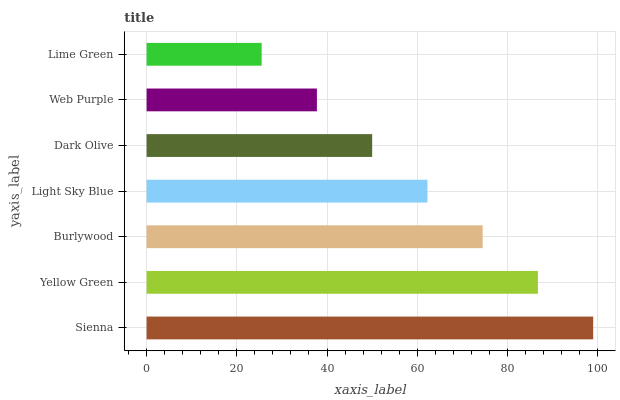Is Lime Green the minimum?
Answer yes or no. Yes. Is Sienna the maximum?
Answer yes or no. Yes. Is Yellow Green the minimum?
Answer yes or no. No. Is Yellow Green the maximum?
Answer yes or no. No. Is Sienna greater than Yellow Green?
Answer yes or no. Yes. Is Yellow Green less than Sienna?
Answer yes or no. Yes. Is Yellow Green greater than Sienna?
Answer yes or no. No. Is Sienna less than Yellow Green?
Answer yes or no. No. Is Light Sky Blue the high median?
Answer yes or no. Yes. Is Light Sky Blue the low median?
Answer yes or no. Yes. Is Web Purple the high median?
Answer yes or no. No. Is Lime Green the low median?
Answer yes or no. No. 